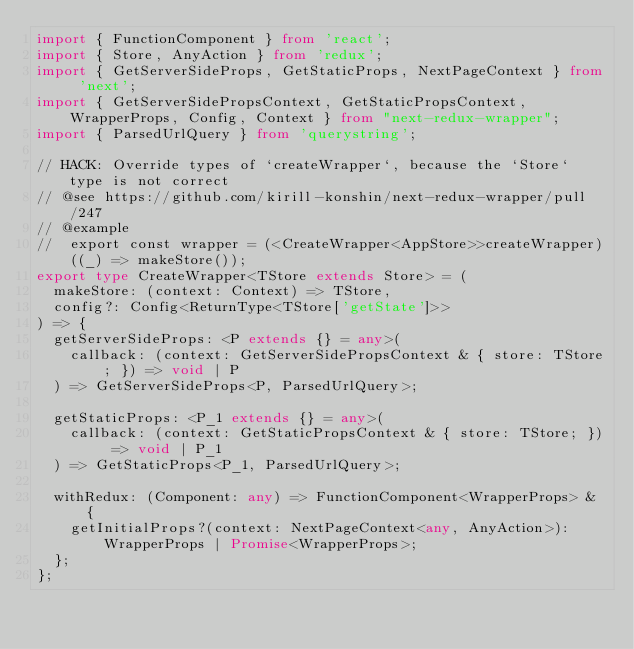Convert code to text. <code><loc_0><loc_0><loc_500><loc_500><_TypeScript_>import { FunctionComponent } from 'react';
import { Store, AnyAction } from 'redux';
import { GetServerSideProps, GetStaticProps, NextPageContext } from 'next';
import { GetServerSidePropsContext, GetStaticPropsContext, WrapperProps, Config, Context } from "next-redux-wrapper";
import { ParsedUrlQuery } from 'querystring';

// HACK: Override types of `createWrapper`, because the `Store` type is not correct
// @see https://github.com/kirill-konshin/next-redux-wrapper/pull/247
// @example
//  export const wrapper = (<CreateWrapper<AppStore>>createWrapper)((_) => makeStore());
export type CreateWrapper<TStore extends Store> = (
  makeStore: (context: Context) => TStore,
  config?: Config<ReturnType<TStore['getState']>>
) => {
  getServerSideProps: <P extends {} = any>(
    callback: (context: GetServerSidePropsContext & { store: TStore; }) => void | P
  ) => GetServerSideProps<P, ParsedUrlQuery>;

  getStaticProps: <P_1 extends {} = any>(
    callback: (context: GetStaticPropsContext & { store: TStore; }) => void | P_1
  ) => GetStaticProps<P_1, ParsedUrlQuery>;

  withRedux: (Component: any) => FunctionComponent<WrapperProps> & {
    getInitialProps?(context: NextPageContext<any, AnyAction>): WrapperProps | Promise<WrapperProps>;
  };
};
</code> 